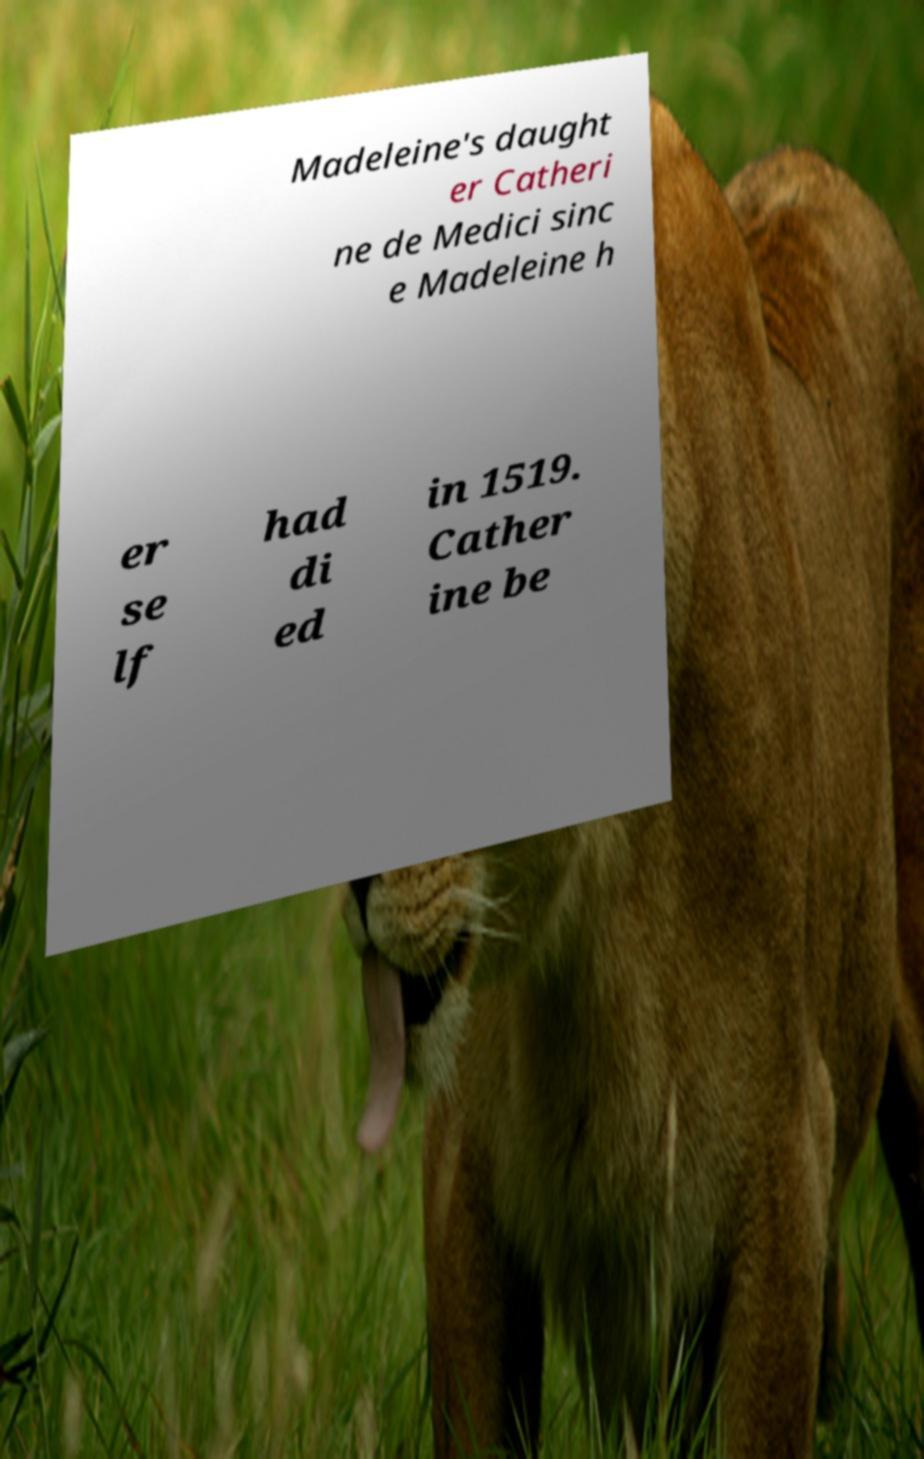Could you assist in decoding the text presented in this image and type it out clearly? Madeleine's daught er Catheri ne de Medici sinc e Madeleine h er se lf had di ed in 1519. Cather ine be 